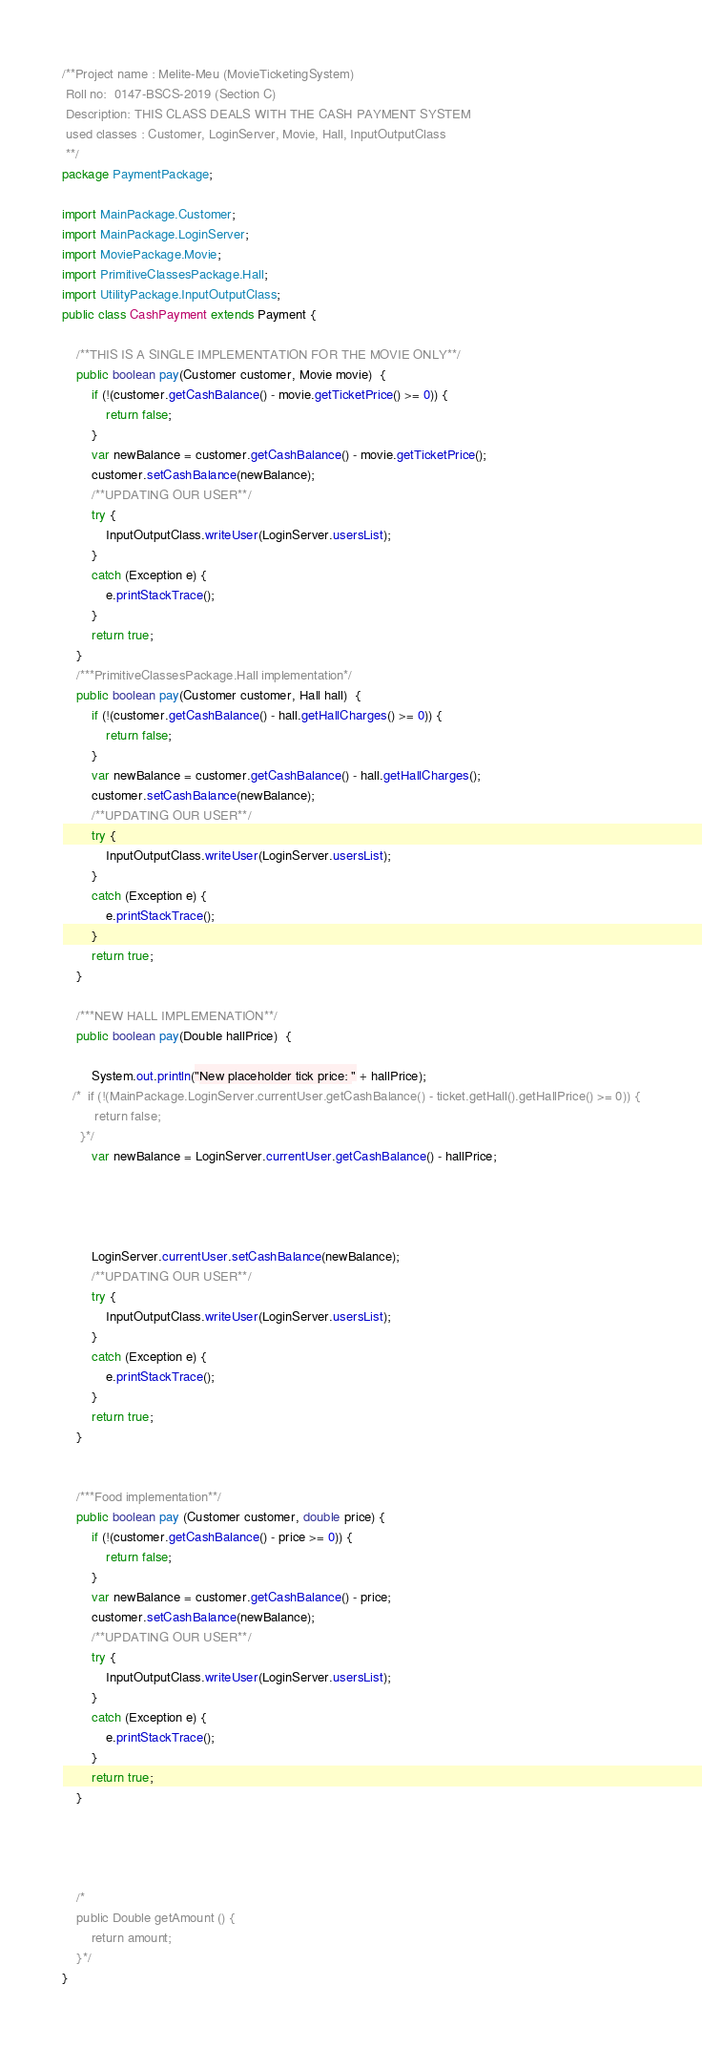<code> <loc_0><loc_0><loc_500><loc_500><_Java_>/**Project name : Melite-Meu (MovieTicketingSystem)
 Roll no:  0147-BSCS-2019 (Section C)
 Description: THIS CLASS DEALS WITH THE CASH PAYMENT SYSTEM
 used classes : Customer, LoginServer, Movie, Hall, InputOutputClass
 **/
package PaymentPackage;

import MainPackage.Customer;
import MainPackage.LoginServer;
import MoviePackage.Movie;
import PrimitiveClassesPackage.Hall;
import UtilityPackage.InputOutputClass;
public class CashPayment extends Payment {

    /**THIS IS A SINGLE IMPLEMENTATION FOR THE MOVIE ONLY**/
    public boolean pay(Customer customer, Movie movie)  {
        if (!(customer.getCashBalance() - movie.getTicketPrice() >= 0)) {
            return false;
        }
        var newBalance = customer.getCashBalance() - movie.getTicketPrice();
        customer.setCashBalance(newBalance);
        /**UPDATING OUR USER**/
        try {
            InputOutputClass.writeUser(LoginServer.usersList);
        }
        catch (Exception e) {
            e.printStackTrace();
        }
        return true;
    }
    /***PrimitiveClassesPackage.Hall implementation*/
    public boolean pay(Customer customer, Hall hall)  {
        if (!(customer.getCashBalance() - hall.getHallCharges() >= 0)) {
            return false;
        }
        var newBalance = customer.getCashBalance() - hall.getHallCharges();
        customer.setCashBalance(newBalance);
        /**UPDATING OUR USER**/
        try {
            InputOutputClass.writeUser(LoginServer.usersList);
        }
        catch (Exception e) {
            e.printStackTrace();
        }
        return true;
    }

    /***NEW HALL IMPLEMENATION**/
    public boolean pay(Double hallPrice)  {

        System.out.println("New placeholder tick price: " + hallPrice);
   /*  if (!(MainPackage.LoginServer.currentUser.getCashBalance() - ticket.getHall().getHallPrice() >= 0)) {
         return false;
     }*/
        var newBalance = LoginServer.currentUser.getCashBalance() - hallPrice;




        LoginServer.currentUser.setCashBalance(newBalance);
        /**UPDATING OUR USER**/
        try {
            InputOutputClass.writeUser(LoginServer.usersList);
        }
        catch (Exception e) {
            e.printStackTrace();
        }
        return true;
    }


    /***Food implementation**/
    public boolean pay (Customer customer, double price) {
        if (!(customer.getCashBalance() - price >= 0)) {
            return false;
        }
        var newBalance = customer.getCashBalance() - price;
        customer.setCashBalance(newBalance);
        /**UPDATING OUR USER**/
        try {
            InputOutputClass.writeUser(LoginServer.usersList);
        }
        catch (Exception e) {
            e.printStackTrace();
        }
        return true;
    }




    /*
    public Double getAmount () {
        return amount;
    }*/
}


</code> 